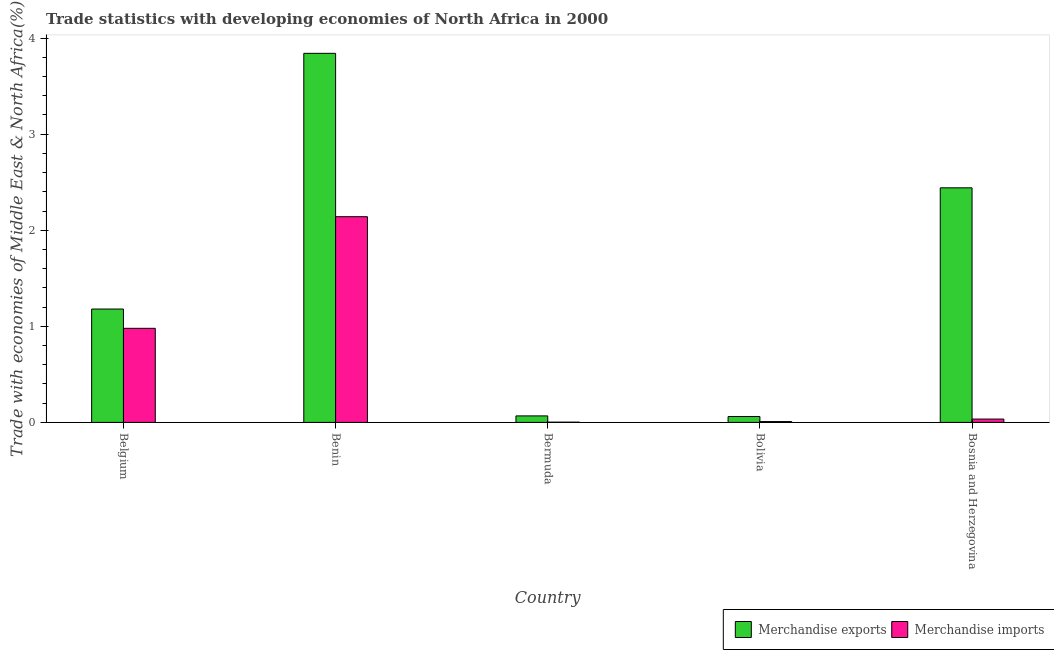How many groups of bars are there?
Keep it short and to the point. 5. Are the number of bars per tick equal to the number of legend labels?
Make the answer very short. Yes. How many bars are there on the 2nd tick from the left?
Your response must be concise. 2. What is the merchandise exports in Belgium?
Your response must be concise. 1.18. Across all countries, what is the maximum merchandise imports?
Offer a terse response. 2.14. Across all countries, what is the minimum merchandise exports?
Give a very brief answer. 0.06. In which country was the merchandise imports maximum?
Your answer should be very brief. Benin. In which country was the merchandise exports minimum?
Your answer should be very brief. Bolivia. What is the total merchandise imports in the graph?
Offer a very short reply. 3.17. What is the difference between the merchandise imports in Bermuda and that in Bolivia?
Offer a terse response. -0.01. What is the difference between the merchandise imports in Bolivia and the merchandise exports in Bosnia and Herzegovina?
Your answer should be very brief. -2.43. What is the average merchandise imports per country?
Provide a short and direct response. 0.63. What is the difference between the merchandise exports and merchandise imports in Benin?
Offer a terse response. 1.7. What is the ratio of the merchandise imports in Belgium to that in Bermuda?
Offer a very short reply. 398.03. Is the difference between the merchandise exports in Benin and Bermuda greater than the difference between the merchandise imports in Benin and Bermuda?
Keep it short and to the point. Yes. What is the difference between the highest and the second highest merchandise exports?
Offer a very short reply. 1.4. What is the difference between the highest and the lowest merchandise exports?
Provide a short and direct response. 3.78. Is the sum of the merchandise exports in Belgium and Bosnia and Herzegovina greater than the maximum merchandise imports across all countries?
Provide a short and direct response. Yes. What is the difference between two consecutive major ticks on the Y-axis?
Offer a terse response. 1. Does the graph contain grids?
Offer a terse response. No. Where does the legend appear in the graph?
Your response must be concise. Bottom right. How are the legend labels stacked?
Your response must be concise. Horizontal. What is the title of the graph?
Keep it short and to the point. Trade statistics with developing economies of North Africa in 2000. What is the label or title of the X-axis?
Provide a succinct answer. Country. What is the label or title of the Y-axis?
Offer a very short reply. Trade with economies of Middle East & North Africa(%). What is the Trade with economies of Middle East & North Africa(%) in Merchandise exports in Belgium?
Your answer should be very brief. 1.18. What is the Trade with economies of Middle East & North Africa(%) in Merchandise imports in Belgium?
Give a very brief answer. 0.98. What is the Trade with economies of Middle East & North Africa(%) in Merchandise exports in Benin?
Ensure brevity in your answer.  3.84. What is the Trade with economies of Middle East & North Africa(%) in Merchandise imports in Benin?
Offer a very short reply. 2.14. What is the Trade with economies of Middle East & North Africa(%) in Merchandise exports in Bermuda?
Provide a succinct answer. 0.07. What is the Trade with economies of Middle East & North Africa(%) in Merchandise imports in Bermuda?
Give a very brief answer. 0. What is the Trade with economies of Middle East & North Africa(%) in Merchandise exports in Bolivia?
Provide a succinct answer. 0.06. What is the Trade with economies of Middle East & North Africa(%) in Merchandise imports in Bolivia?
Ensure brevity in your answer.  0.01. What is the Trade with economies of Middle East & North Africa(%) of Merchandise exports in Bosnia and Herzegovina?
Your answer should be very brief. 2.44. What is the Trade with economies of Middle East & North Africa(%) of Merchandise imports in Bosnia and Herzegovina?
Your answer should be very brief. 0.03. Across all countries, what is the maximum Trade with economies of Middle East & North Africa(%) of Merchandise exports?
Offer a very short reply. 3.84. Across all countries, what is the maximum Trade with economies of Middle East & North Africa(%) of Merchandise imports?
Make the answer very short. 2.14. Across all countries, what is the minimum Trade with economies of Middle East & North Africa(%) of Merchandise exports?
Your answer should be compact. 0.06. Across all countries, what is the minimum Trade with economies of Middle East & North Africa(%) of Merchandise imports?
Your response must be concise. 0. What is the total Trade with economies of Middle East & North Africa(%) of Merchandise exports in the graph?
Give a very brief answer. 7.59. What is the total Trade with economies of Middle East & North Africa(%) of Merchandise imports in the graph?
Ensure brevity in your answer.  3.17. What is the difference between the Trade with economies of Middle East & North Africa(%) of Merchandise exports in Belgium and that in Benin?
Your answer should be very brief. -2.66. What is the difference between the Trade with economies of Middle East & North Africa(%) of Merchandise imports in Belgium and that in Benin?
Offer a very short reply. -1.16. What is the difference between the Trade with economies of Middle East & North Africa(%) in Merchandise exports in Belgium and that in Bermuda?
Your response must be concise. 1.11. What is the difference between the Trade with economies of Middle East & North Africa(%) in Merchandise imports in Belgium and that in Bermuda?
Offer a very short reply. 0.98. What is the difference between the Trade with economies of Middle East & North Africa(%) of Merchandise exports in Belgium and that in Bolivia?
Ensure brevity in your answer.  1.12. What is the difference between the Trade with economies of Middle East & North Africa(%) in Merchandise imports in Belgium and that in Bolivia?
Offer a very short reply. 0.97. What is the difference between the Trade with economies of Middle East & North Africa(%) in Merchandise exports in Belgium and that in Bosnia and Herzegovina?
Keep it short and to the point. -1.26. What is the difference between the Trade with economies of Middle East & North Africa(%) in Merchandise imports in Belgium and that in Bosnia and Herzegovina?
Ensure brevity in your answer.  0.94. What is the difference between the Trade with economies of Middle East & North Africa(%) of Merchandise exports in Benin and that in Bermuda?
Offer a very short reply. 3.77. What is the difference between the Trade with economies of Middle East & North Africa(%) in Merchandise imports in Benin and that in Bermuda?
Offer a terse response. 2.14. What is the difference between the Trade with economies of Middle East & North Africa(%) in Merchandise exports in Benin and that in Bolivia?
Your answer should be very brief. 3.78. What is the difference between the Trade with economies of Middle East & North Africa(%) of Merchandise imports in Benin and that in Bolivia?
Give a very brief answer. 2.13. What is the difference between the Trade with economies of Middle East & North Africa(%) of Merchandise exports in Benin and that in Bosnia and Herzegovina?
Your answer should be very brief. 1.4. What is the difference between the Trade with economies of Middle East & North Africa(%) of Merchandise imports in Benin and that in Bosnia and Herzegovina?
Offer a very short reply. 2.11. What is the difference between the Trade with economies of Middle East & North Africa(%) of Merchandise exports in Bermuda and that in Bolivia?
Make the answer very short. 0.01. What is the difference between the Trade with economies of Middle East & North Africa(%) of Merchandise imports in Bermuda and that in Bolivia?
Provide a short and direct response. -0.01. What is the difference between the Trade with economies of Middle East & North Africa(%) in Merchandise exports in Bermuda and that in Bosnia and Herzegovina?
Keep it short and to the point. -2.37. What is the difference between the Trade with economies of Middle East & North Africa(%) of Merchandise imports in Bermuda and that in Bosnia and Herzegovina?
Provide a succinct answer. -0.03. What is the difference between the Trade with economies of Middle East & North Africa(%) in Merchandise exports in Bolivia and that in Bosnia and Herzegovina?
Provide a succinct answer. -2.38. What is the difference between the Trade with economies of Middle East & North Africa(%) of Merchandise imports in Bolivia and that in Bosnia and Herzegovina?
Your answer should be very brief. -0.03. What is the difference between the Trade with economies of Middle East & North Africa(%) of Merchandise exports in Belgium and the Trade with economies of Middle East & North Africa(%) of Merchandise imports in Benin?
Make the answer very short. -0.96. What is the difference between the Trade with economies of Middle East & North Africa(%) in Merchandise exports in Belgium and the Trade with economies of Middle East & North Africa(%) in Merchandise imports in Bermuda?
Your answer should be very brief. 1.18. What is the difference between the Trade with economies of Middle East & North Africa(%) of Merchandise exports in Belgium and the Trade with economies of Middle East & North Africa(%) of Merchandise imports in Bolivia?
Make the answer very short. 1.17. What is the difference between the Trade with economies of Middle East & North Africa(%) in Merchandise exports in Belgium and the Trade with economies of Middle East & North Africa(%) in Merchandise imports in Bosnia and Herzegovina?
Ensure brevity in your answer.  1.15. What is the difference between the Trade with economies of Middle East & North Africa(%) in Merchandise exports in Benin and the Trade with economies of Middle East & North Africa(%) in Merchandise imports in Bermuda?
Offer a very short reply. 3.84. What is the difference between the Trade with economies of Middle East & North Africa(%) in Merchandise exports in Benin and the Trade with economies of Middle East & North Africa(%) in Merchandise imports in Bolivia?
Provide a succinct answer. 3.83. What is the difference between the Trade with economies of Middle East & North Africa(%) in Merchandise exports in Benin and the Trade with economies of Middle East & North Africa(%) in Merchandise imports in Bosnia and Herzegovina?
Keep it short and to the point. 3.81. What is the difference between the Trade with economies of Middle East & North Africa(%) of Merchandise exports in Bermuda and the Trade with economies of Middle East & North Africa(%) of Merchandise imports in Bolivia?
Your response must be concise. 0.06. What is the difference between the Trade with economies of Middle East & North Africa(%) of Merchandise exports in Bermuda and the Trade with economies of Middle East & North Africa(%) of Merchandise imports in Bosnia and Herzegovina?
Provide a succinct answer. 0.03. What is the difference between the Trade with economies of Middle East & North Africa(%) of Merchandise exports in Bolivia and the Trade with economies of Middle East & North Africa(%) of Merchandise imports in Bosnia and Herzegovina?
Your response must be concise. 0.03. What is the average Trade with economies of Middle East & North Africa(%) of Merchandise exports per country?
Your answer should be compact. 1.52. What is the average Trade with economies of Middle East & North Africa(%) in Merchandise imports per country?
Make the answer very short. 0.63. What is the difference between the Trade with economies of Middle East & North Africa(%) in Merchandise exports and Trade with economies of Middle East & North Africa(%) in Merchandise imports in Belgium?
Your answer should be very brief. 0.2. What is the difference between the Trade with economies of Middle East & North Africa(%) of Merchandise exports and Trade with economies of Middle East & North Africa(%) of Merchandise imports in Benin?
Make the answer very short. 1.7. What is the difference between the Trade with economies of Middle East & North Africa(%) in Merchandise exports and Trade with economies of Middle East & North Africa(%) in Merchandise imports in Bermuda?
Give a very brief answer. 0.07. What is the difference between the Trade with economies of Middle East & North Africa(%) in Merchandise exports and Trade with economies of Middle East & North Africa(%) in Merchandise imports in Bolivia?
Keep it short and to the point. 0.05. What is the difference between the Trade with economies of Middle East & North Africa(%) in Merchandise exports and Trade with economies of Middle East & North Africa(%) in Merchandise imports in Bosnia and Herzegovina?
Make the answer very short. 2.41. What is the ratio of the Trade with economies of Middle East & North Africa(%) of Merchandise exports in Belgium to that in Benin?
Give a very brief answer. 0.31. What is the ratio of the Trade with economies of Middle East & North Africa(%) of Merchandise imports in Belgium to that in Benin?
Your answer should be very brief. 0.46. What is the ratio of the Trade with economies of Middle East & North Africa(%) of Merchandise exports in Belgium to that in Bermuda?
Make the answer very short. 17.46. What is the ratio of the Trade with economies of Middle East & North Africa(%) in Merchandise imports in Belgium to that in Bermuda?
Provide a succinct answer. 398.03. What is the ratio of the Trade with economies of Middle East & North Africa(%) in Merchandise exports in Belgium to that in Bolivia?
Offer a terse response. 19.29. What is the ratio of the Trade with economies of Middle East & North Africa(%) in Merchandise imports in Belgium to that in Bolivia?
Offer a terse response. 112.86. What is the ratio of the Trade with economies of Middle East & North Africa(%) of Merchandise exports in Belgium to that in Bosnia and Herzegovina?
Your answer should be compact. 0.48. What is the ratio of the Trade with economies of Middle East & North Africa(%) of Merchandise imports in Belgium to that in Bosnia and Herzegovina?
Provide a succinct answer. 28.34. What is the ratio of the Trade with economies of Middle East & North Africa(%) in Merchandise exports in Benin to that in Bermuda?
Keep it short and to the point. 56.86. What is the ratio of the Trade with economies of Middle East & North Africa(%) in Merchandise imports in Benin to that in Bermuda?
Ensure brevity in your answer.  870.33. What is the ratio of the Trade with economies of Middle East & North Africa(%) in Merchandise exports in Benin to that in Bolivia?
Give a very brief answer. 62.82. What is the ratio of the Trade with economies of Middle East & North Africa(%) in Merchandise imports in Benin to that in Bolivia?
Keep it short and to the point. 246.78. What is the ratio of the Trade with economies of Middle East & North Africa(%) of Merchandise exports in Benin to that in Bosnia and Herzegovina?
Ensure brevity in your answer.  1.57. What is the ratio of the Trade with economies of Middle East & North Africa(%) in Merchandise imports in Benin to that in Bosnia and Herzegovina?
Offer a terse response. 61.97. What is the ratio of the Trade with economies of Middle East & North Africa(%) in Merchandise exports in Bermuda to that in Bolivia?
Make the answer very short. 1.1. What is the ratio of the Trade with economies of Middle East & North Africa(%) of Merchandise imports in Bermuda to that in Bolivia?
Provide a succinct answer. 0.28. What is the ratio of the Trade with economies of Middle East & North Africa(%) of Merchandise exports in Bermuda to that in Bosnia and Herzegovina?
Keep it short and to the point. 0.03. What is the ratio of the Trade with economies of Middle East & North Africa(%) in Merchandise imports in Bermuda to that in Bosnia and Herzegovina?
Offer a very short reply. 0.07. What is the ratio of the Trade with economies of Middle East & North Africa(%) in Merchandise exports in Bolivia to that in Bosnia and Herzegovina?
Give a very brief answer. 0.03. What is the ratio of the Trade with economies of Middle East & North Africa(%) in Merchandise imports in Bolivia to that in Bosnia and Herzegovina?
Ensure brevity in your answer.  0.25. What is the difference between the highest and the second highest Trade with economies of Middle East & North Africa(%) of Merchandise exports?
Offer a terse response. 1.4. What is the difference between the highest and the second highest Trade with economies of Middle East & North Africa(%) of Merchandise imports?
Offer a very short reply. 1.16. What is the difference between the highest and the lowest Trade with economies of Middle East & North Africa(%) in Merchandise exports?
Your answer should be very brief. 3.78. What is the difference between the highest and the lowest Trade with economies of Middle East & North Africa(%) in Merchandise imports?
Offer a terse response. 2.14. 